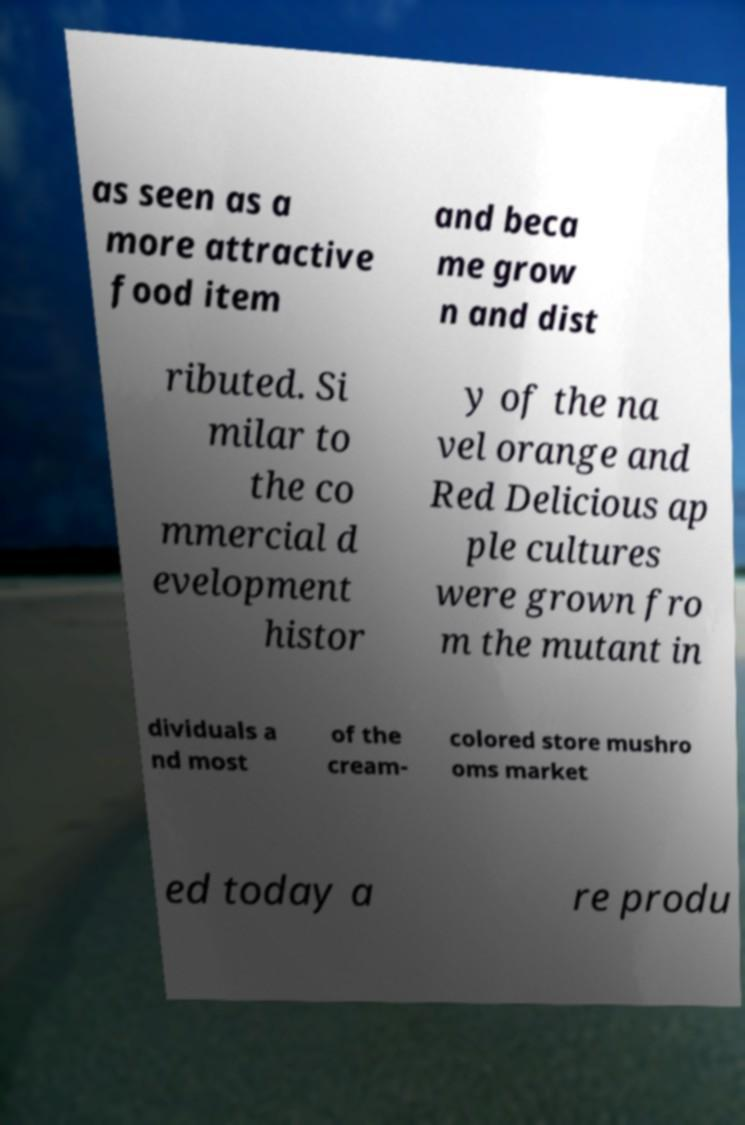There's text embedded in this image that I need extracted. Can you transcribe it verbatim? as seen as a more attractive food item and beca me grow n and dist ributed. Si milar to the co mmercial d evelopment histor y of the na vel orange and Red Delicious ap ple cultures were grown fro m the mutant in dividuals a nd most of the cream- colored store mushro oms market ed today a re produ 